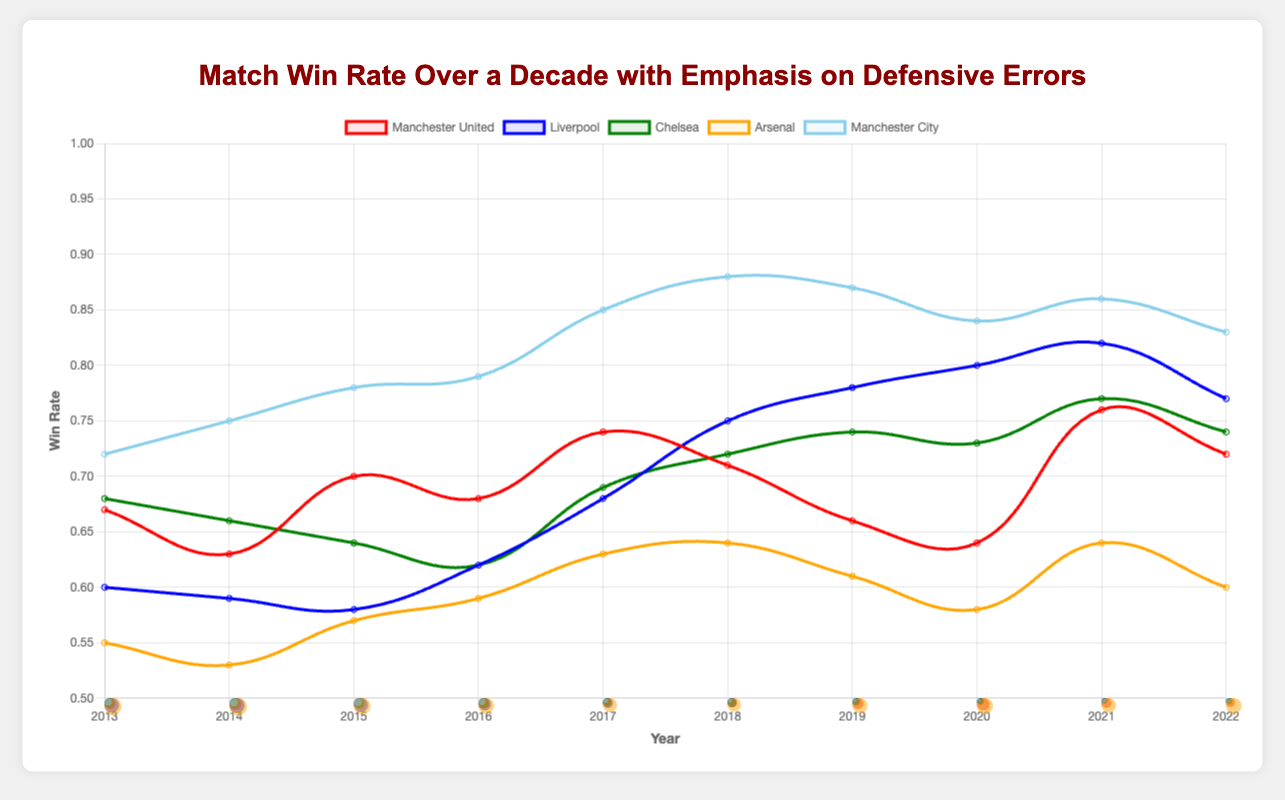Which team had the highest win rate in 2022? By looking at the line chart for the year 2022, we can identify that Manchester City had the highest win rate.
Answer: Manchester City What is the average win rate of Liverpool over the decade? To compute the average win rate, sum up Liverpool's win rates for each year and divide by the number of years. The win rates are [0.6, 0.59, 0.58, 0.62, 0.68, 0.75, 0.78, 0.80, 0.82, 0.77]. Adding these, we get 6.39. Dividing by 10 years gives 0.639.
Answer: 0.639 Which team had the most defensive errors in 2014, and how many were they? By observing the data points for defensive errors in 2014, we see that Arsenal had the most errors, totaling 35.
Answer: Arsenal, 35 Compare the win rate trends of Manchester United and Arsenal. Which team showed more improvement over the decade? To compare trends, we look at the start and end win rates for each team from 2013 to 2022. Manchester United started at 0.67 and ended at 0.72 (+0.05), while Arsenal started at 0.55 and ended at 0.60 (+0.05). Both teams showed an equal improvement of 0.05.
Answer: Both, 0.05 increase What is the relationship between Manchester City’s win rate and defensive errors over the decade? Manchester City's win rate increased from 0.72 to 0.83 over the decade while defensive errors decreased from 15 to 8. This inverse relationship suggests that as their defensive errors decreased, their win rate improved.
Answer: Inverse relationship Across the decade, which year saw the lowest defensive errors for Chelsea, and what was the number? Looking at Chelsea’s defensive errors over the decade, the lowest number of errors occurred in 2021, with 12 defensive errors.
Answer: 2021, 12 How did Liverpool's win rate in 2020 compare to its win rate in 2013? Liverpool's win rate in 2020 was 0.80, and in 2013 it was 0.60. Subtract the win rate of 2013 from 2020 to find the difference: 0.80 - 0.60 = 0.20. Thus, Liverpool’s win rate increased by 0.20.
Answer: Increased by 0.20 What is the average number of defensive errors for Arsenal from 2013 to 2022? To find the average, sum Arsenal's defensive errors for each year and divide by the number of years. The errors are [34, 35, 33, 31, 28, 27, 30, 32, 29, 31]. Adding these results in 310. Dividing by 10, the average is 310/10 = 31.
Answer: 31 Which team had the highest and lowest win rate in 2016? In 2016, Manchester City had the highest win rate at 0.79, and Liverpool had the lowest win rate at 0.62.
Answer: Manchester City, Liverpool 